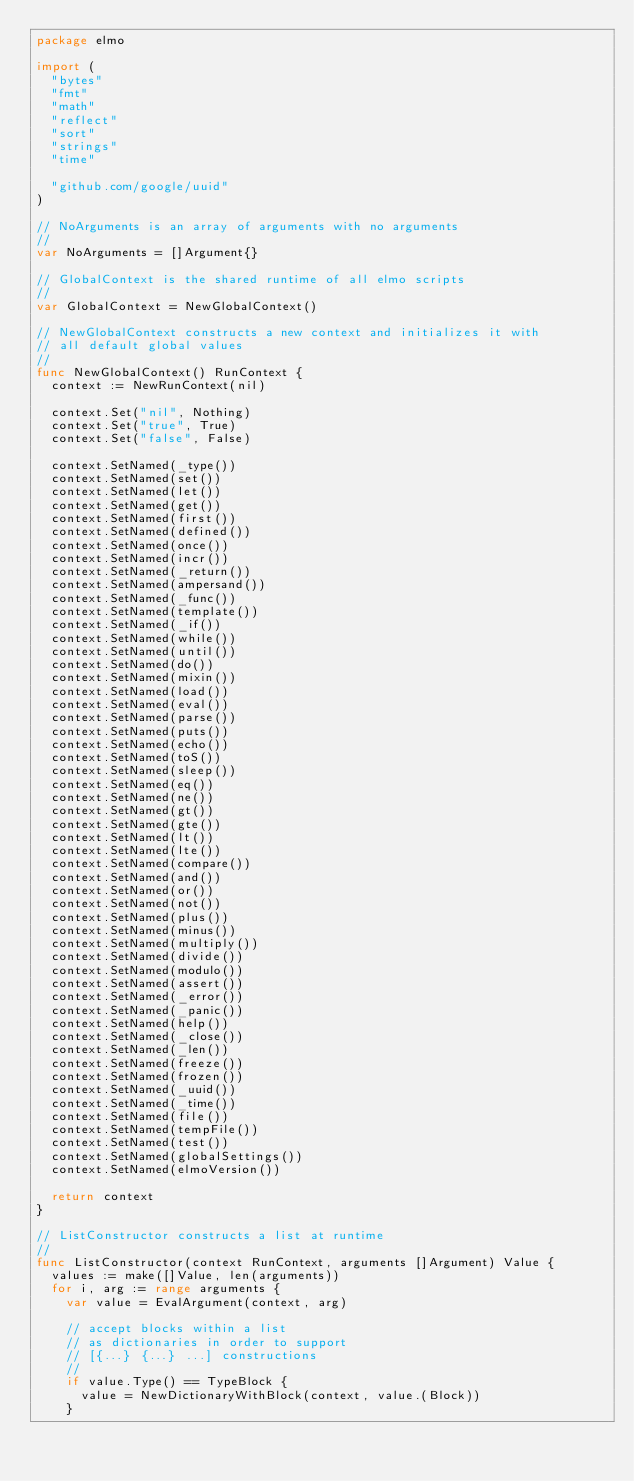<code> <loc_0><loc_0><loc_500><loc_500><_Go_>package elmo

import (
	"bytes"
	"fmt"
	"math"
	"reflect"
	"sort"
	"strings"
	"time"

	"github.com/google/uuid"
)

// NoArguments is an array of arguments with no arguments
//
var NoArguments = []Argument{}

// GlobalContext is the shared runtime of all elmo scripts
//
var GlobalContext = NewGlobalContext()

// NewGlobalContext constructs a new context and initializes it with
// all default global values
//
func NewGlobalContext() RunContext {
	context := NewRunContext(nil)

	context.Set("nil", Nothing)
	context.Set("true", True)
	context.Set("false", False)

	context.SetNamed(_type())
	context.SetNamed(set())
	context.SetNamed(let())
	context.SetNamed(get())
	context.SetNamed(first())
	context.SetNamed(defined())
	context.SetNamed(once())
	context.SetNamed(incr())
	context.SetNamed(_return())
	context.SetNamed(ampersand())
	context.SetNamed(_func())
	context.SetNamed(template())
	context.SetNamed(_if())
	context.SetNamed(while())
	context.SetNamed(until())
	context.SetNamed(do())
	context.SetNamed(mixin())
	context.SetNamed(load())
	context.SetNamed(eval())
	context.SetNamed(parse())
	context.SetNamed(puts())
	context.SetNamed(echo())
	context.SetNamed(toS())
	context.SetNamed(sleep())
	context.SetNamed(eq())
	context.SetNamed(ne())
	context.SetNamed(gt())
	context.SetNamed(gte())
	context.SetNamed(lt())
	context.SetNamed(lte())
	context.SetNamed(compare())
	context.SetNamed(and())
	context.SetNamed(or())
	context.SetNamed(not())
	context.SetNamed(plus())
	context.SetNamed(minus())
	context.SetNamed(multiply())
	context.SetNamed(divide())
	context.SetNamed(modulo())
	context.SetNamed(assert())
	context.SetNamed(_error())
	context.SetNamed(_panic())
	context.SetNamed(help())
	context.SetNamed(_close())
	context.SetNamed(_len())
	context.SetNamed(freeze())
	context.SetNamed(frozen())
	context.SetNamed(_uuid())
	context.SetNamed(_time())
	context.SetNamed(file())
	context.SetNamed(tempFile())
	context.SetNamed(test())
	context.SetNamed(globalSettings())
	context.SetNamed(elmoVersion())

	return context
}

// ListConstructor constructs a list at runtime
//
func ListConstructor(context RunContext, arguments []Argument) Value {
	values := make([]Value, len(arguments))
	for i, arg := range arguments {
		var value = EvalArgument(context, arg)

		// accept blocks within a list
		// as dictionaries in order to support
		// [{...} {...} ...] constructions
		//
		if value.Type() == TypeBlock {
			value = NewDictionaryWithBlock(context, value.(Block))
		}
</code> 